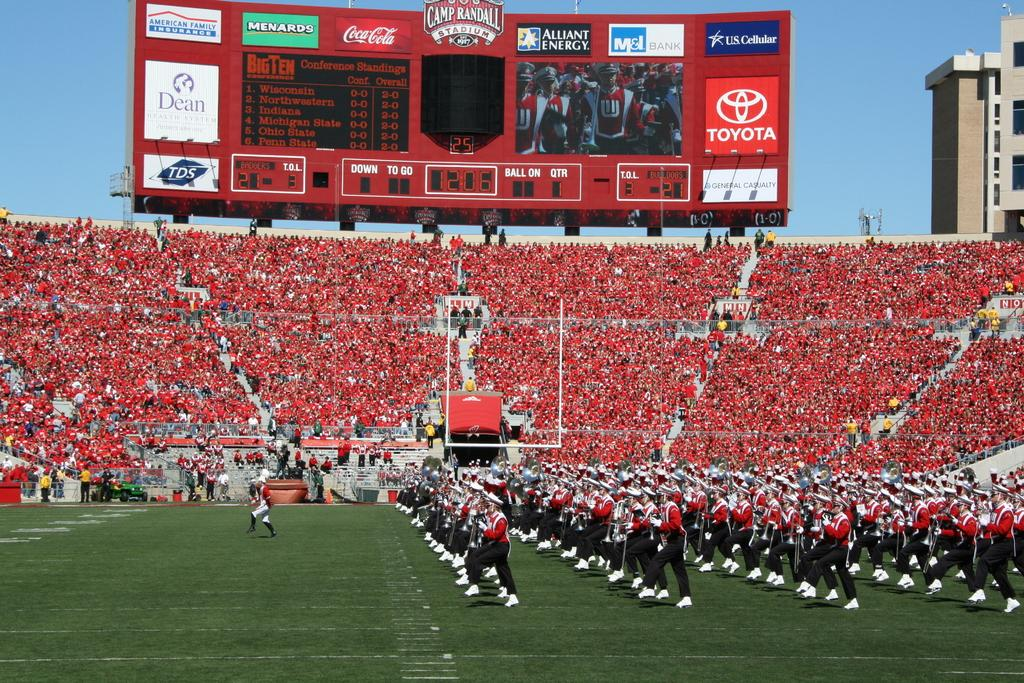<image>
Give a short and clear explanation of the subsequent image. Jumbo Screen on a football field with a marching band, Company sponsors such as: Toyota, Coca Cola, and Menards. 